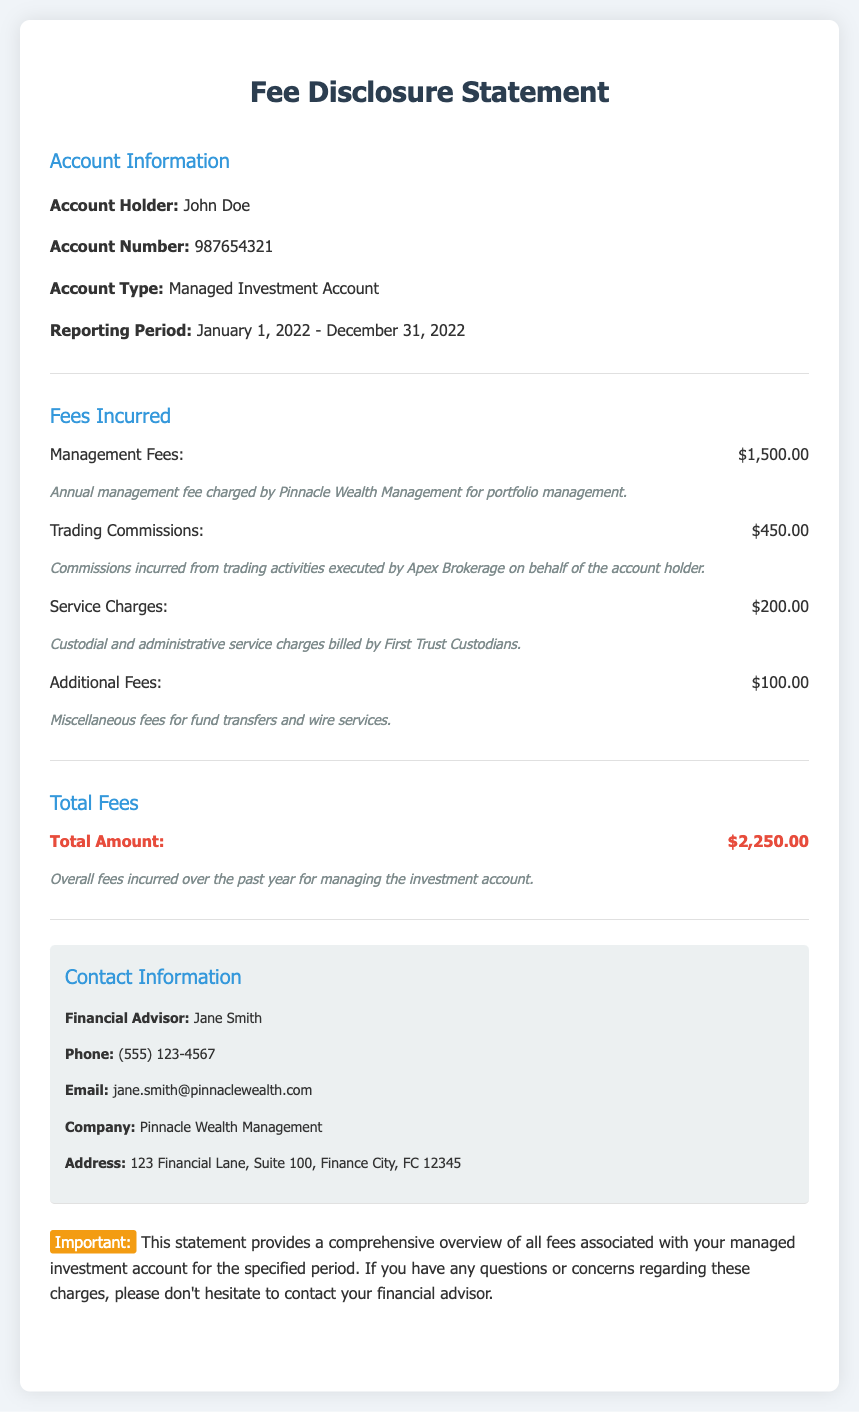What is the account holder's name? The account holder's name is specified in the document under account information.
Answer: John Doe What is the account number? The account number is provided under the account information section.
Answer: 987654321 What were the total management fees incurred? Total management fees are listed in the fees incurred section.
Answer: $1,500.00 What is the total amount of fees incurred over the past year? The total amount is detailed in the total fees section of the document.
Answer: $2,250.00 Which company charged the management fees? The company responsible for the management fees is stated in the fee description.
Answer: Pinnacle Wealth Management What were the trading commissions incurred? The trading commissions can be found in the fees incurred section of the statement.
Answer: $450.00 What type of account is this statement for? The account type is specified in the account information section.
Answer: Managed Investment Account Who is the financial advisor? The financial advisor's name is mentioned in the contact information section.
Answer: Jane Smith What is the phone number for the financial advisor? The phone number is listed under the contact information section.
Answer: (555) 123-4567 